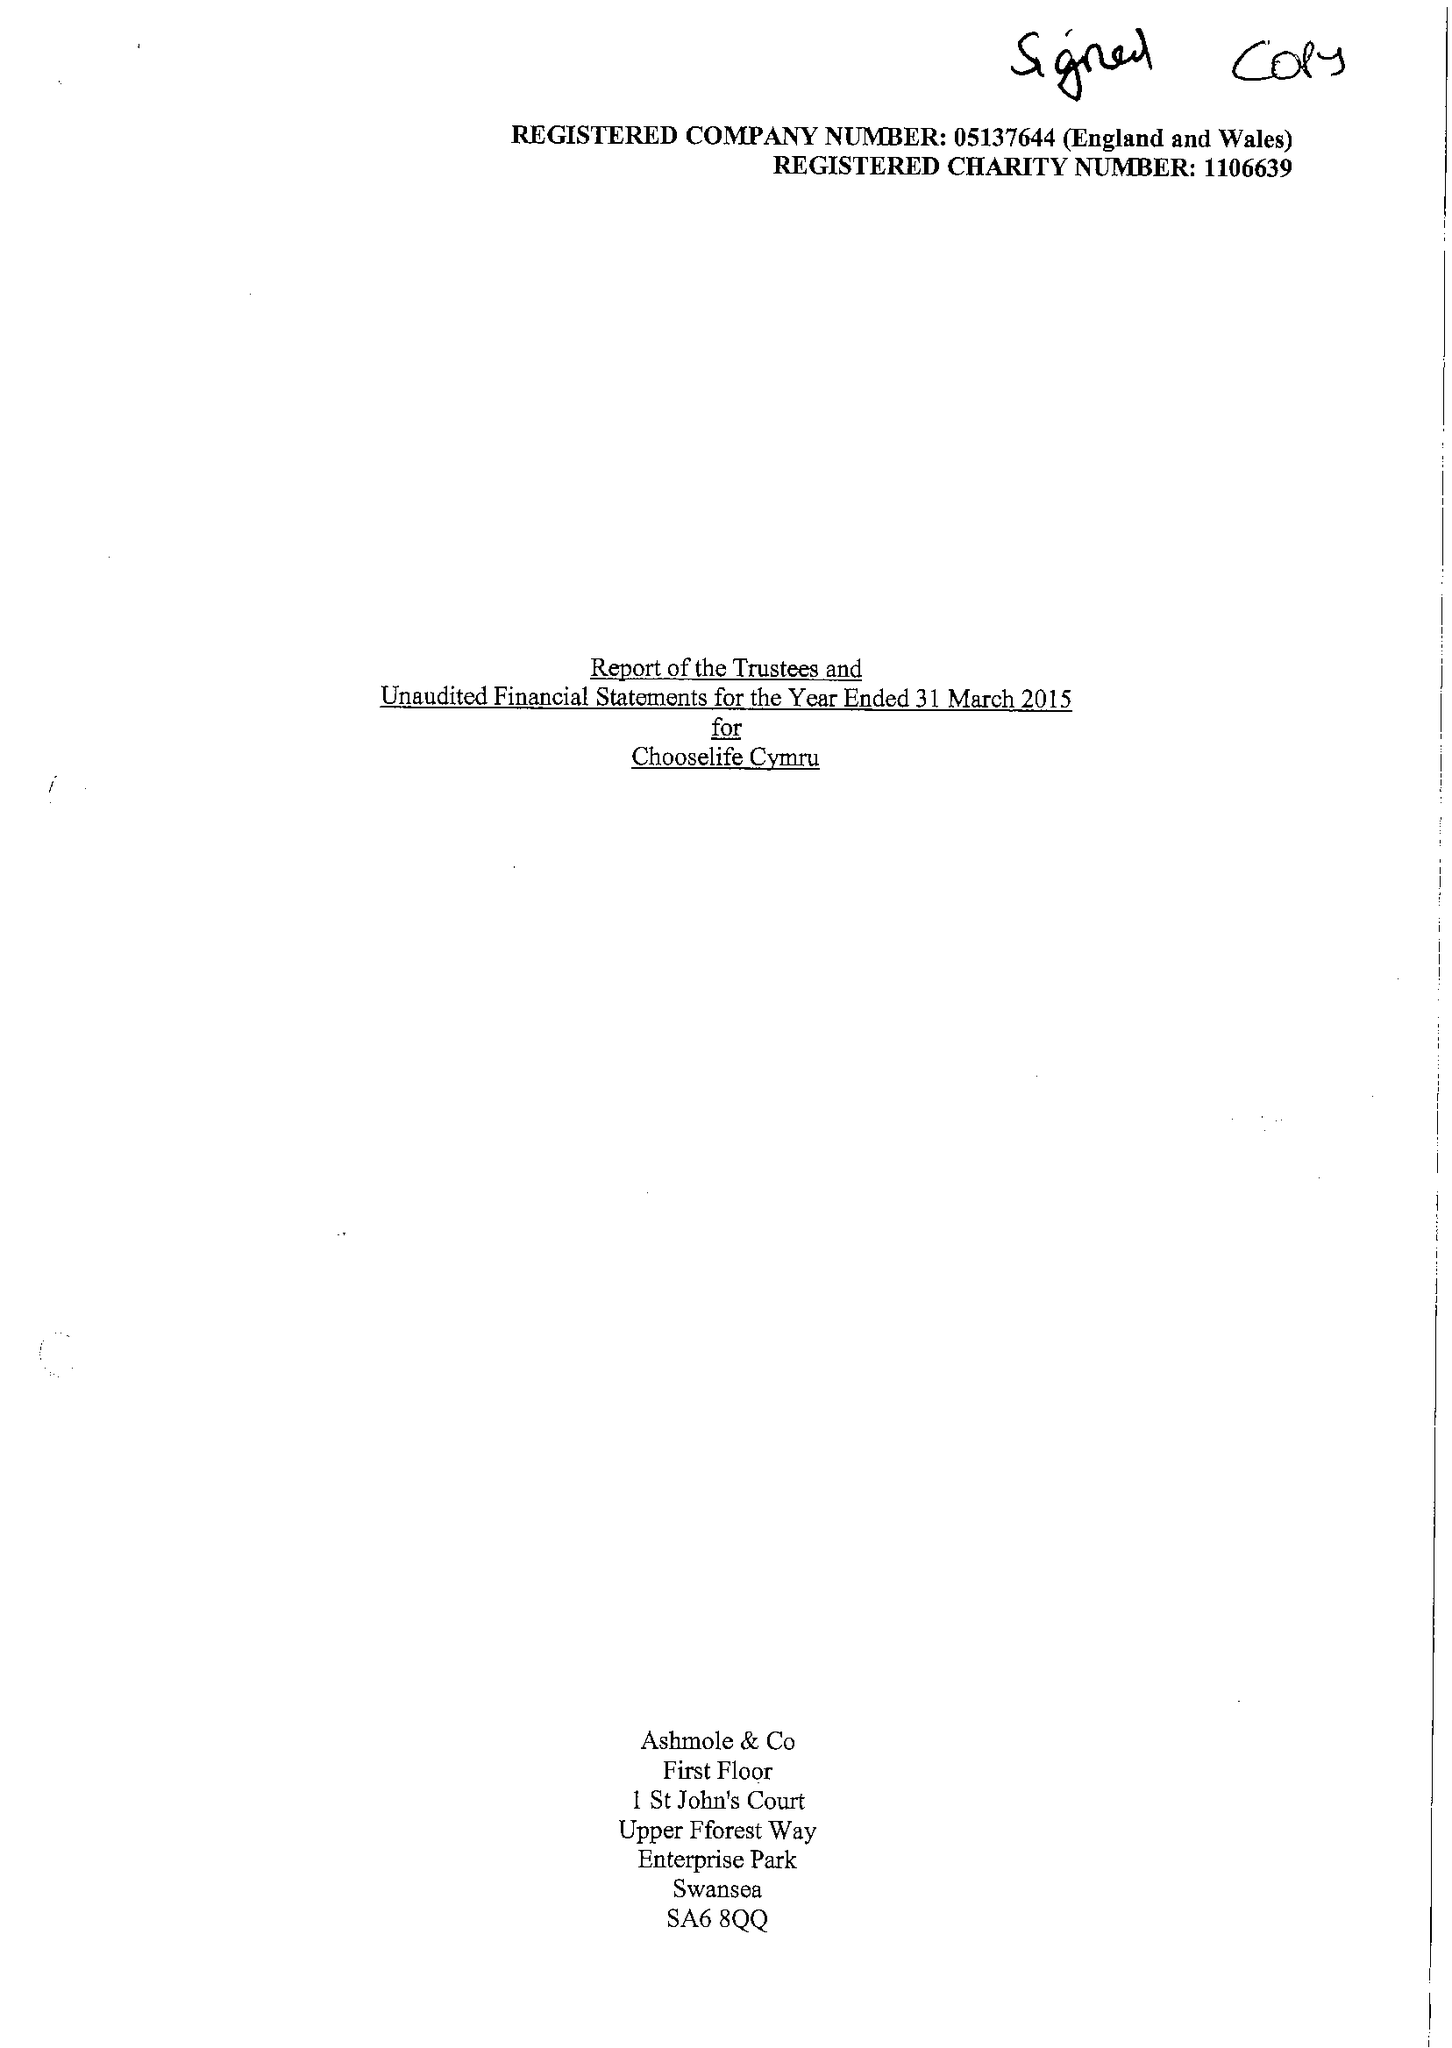What is the value for the charity_number?
Answer the question using a single word or phrase. 1106639 